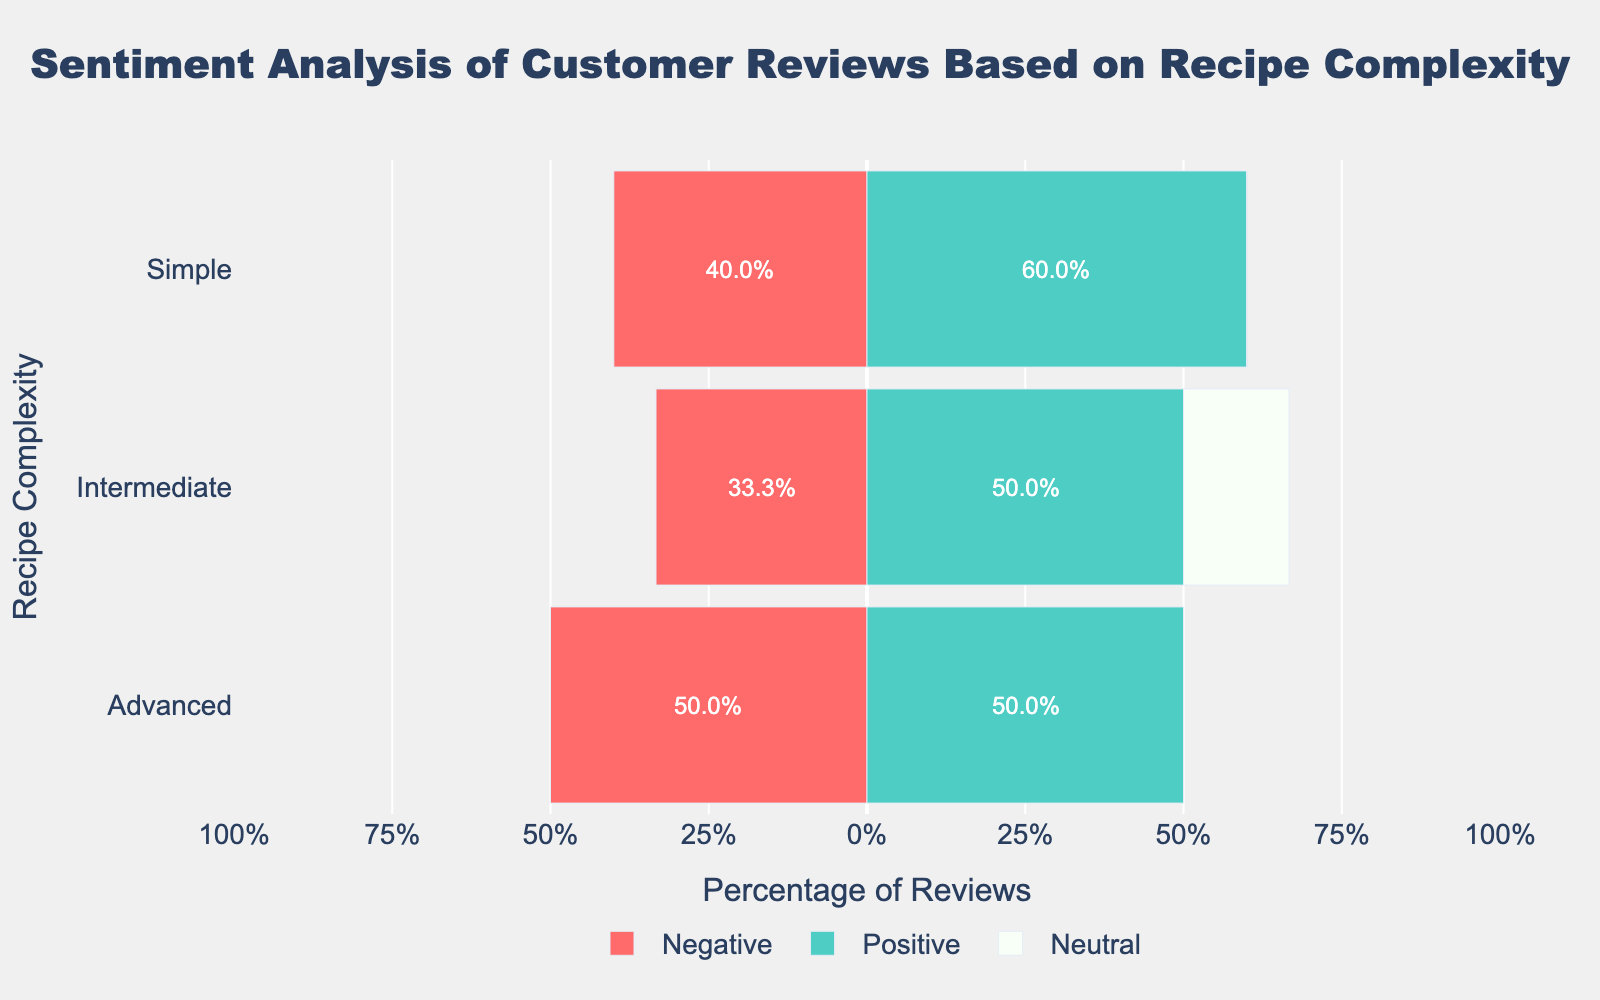What percentage of positive reviews does the 'Simple' complexity group have compared to the 'Advanced' complexity group? To find the percentage of positive reviews for each complexity, locate the green bars for 'Simple' and 'Advanced' in the chart and read off their lengths. The 'Simple' complexity has around 66.7% positive reviews, and the 'Advanced' complexity has around 50% positive reviews.
Answer: Simple: 66.7%, Advanced: 50% Which complexity group has the highest proportion of negative reviews? Look at the red bars for each complexity group in the chart; the longest red bar indicates the highest proportion of negative reviews. The 'Advanced' complexity group has the highest negative reviews proportion.
Answer: Advanced How does the proportion of positive reviews for the 'Intermediate' complexity group compare to its negative reviews? Compare the length of the green bar (positive reviews) to the red bar (negative reviews) for the 'Intermediate' complexity group. The green bar (around 62.5%) is longer than the red bar (around 25%).
Answer: Positive reviews are higher Which complexity group has the smallest percentage of neutral reviews? Look at the white bars (neutral reviews) for each complexity group and identify the shortest bar. The 'Simple' complexity group has no neutral reviews.
Answer: Simple Compute the difference in percentages between positive and negative reviews for the 'Advanced' complexity group. Identify the lengths of the green bar (positive: 50%) and the red bar (negative: -50%) for the 'Advanced' group. Subtract the negative percentage from the positive: 50% - (-50%) = 100%.
Answer: 100% How does the distribution of total negative reviews across all complexity levels compare? Sum the lengths of the red bars for each complexity group. The 'Advanced' group seems to have the highest total, followed by 'Intermediate', and 'Simple' has the least.
Answer: Advanced > Intermediate > Simple What percentage of the total reviews is neutral across all complexity levels? Sum the lengths of the white bars across all complexity groups. The 'Intermediate' complexity has around 12.5% neutral reviews; the other groups have none. So, it's 12.5% of the total.
Answer: 12.5% In the 'Intermediate' complexity, what proportion of reviews are either positive or neutral? Add the percentages of the green (positive: 62.5%) and white (neutral: 12.5%) bars for the 'Intermediate' complexity: 62.5% + 12.5% = 75%.
Answer: 75% 